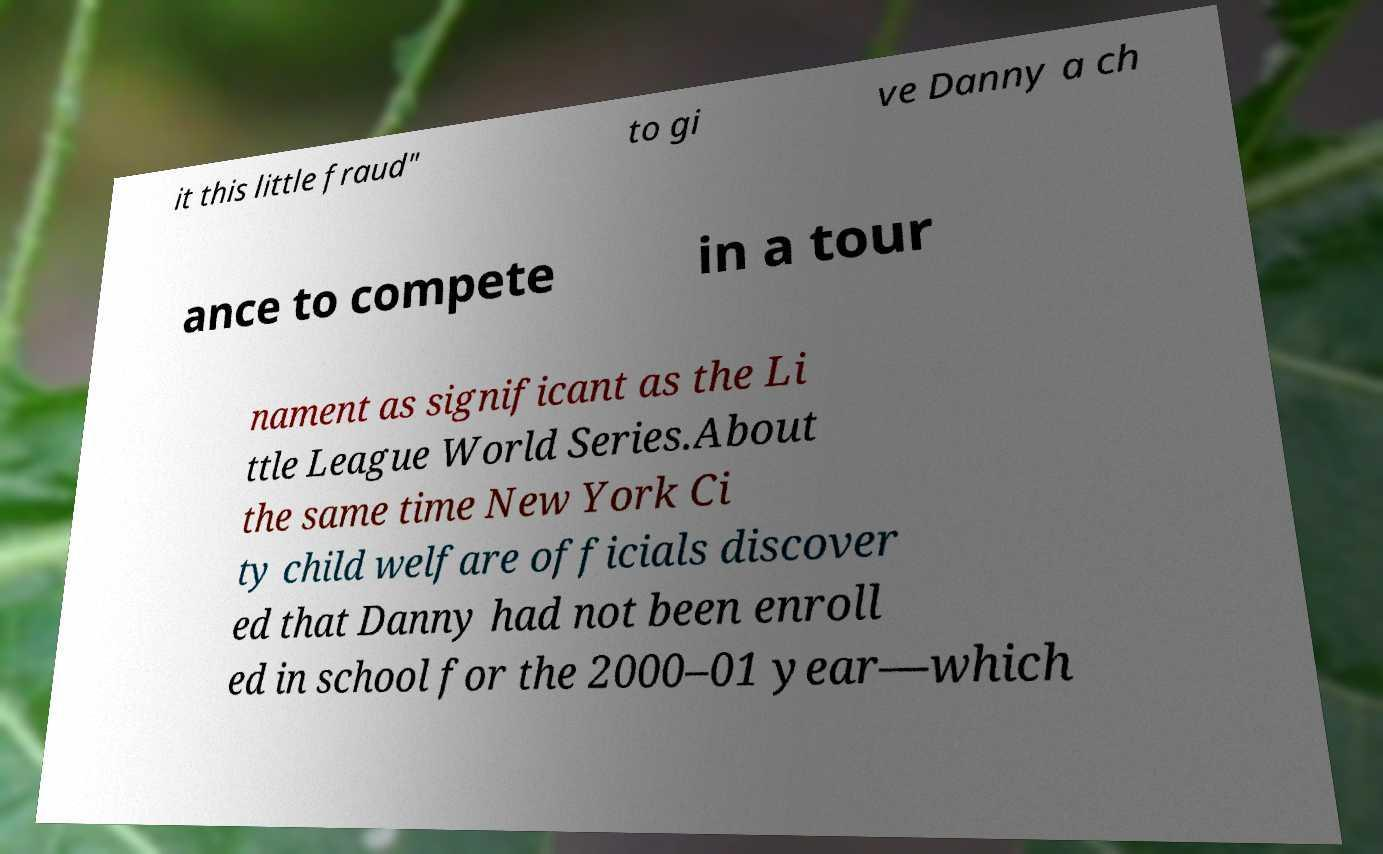For documentation purposes, I need the text within this image transcribed. Could you provide that? it this little fraud" to gi ve Danny a ch ance to compete in a tour nament as significant as the Li ttle League World Series.About the same time New York Ci ty child welfare officials discover ed that Danny had not been enroll ed in school for the 2000–01 year—which 